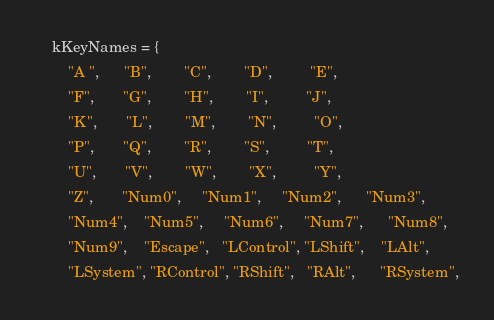Convert code to text. <code><loc_0><loc_0><loc_500><loc_500><_C++_>    kKeyNames = {
        "A ",      "B",        "C",        "D",         "E",
        "F",       "G",        "H",        "I",         "J",
        "K",       "L",        "M",        "N",         "O",
        "P",       "Q",        "R",        "S",         "T",
        "U",       "V",        "W",        "X",         "Y",
        "Z",       "Num0",     "Num1",     "Num2",      "Num3",
        "Num4",    "Num5",     "Num6",     "Num7",      "Num8",
        "Num9",    "Escape",   "LControl", "LShift",    "LAlt",
        "LSystem", "RControl", "RShift",   "RAlt",      "RSystem",</code> 